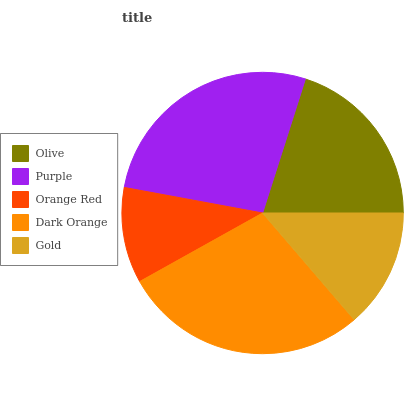Is Orange Red the minimum?
Answer yes or no. Yes. Is Dark Orange the maximum?
Answer yes or no. Yes. Is Purple the minimum?
Answer yes or no. No. Is Purple the maximum?
Answer yes or no. No. Is Purple greater than Olive?
Answer yes or no. Yes. Is Olive less than Purple?
Answer yes or no. Yes. Is Olive greater than Purple?
Answer yes or no. No. Is Purple less than Olive?
Answer yes or no. No. Is Olive the high median?
Answer yes or no. Yes. Is Olive the low median?
Answer yes or no. Yes. Is Purple the high median?
Answer yes or no. No. Is Purple the low median?
Answer yes or no. No. 